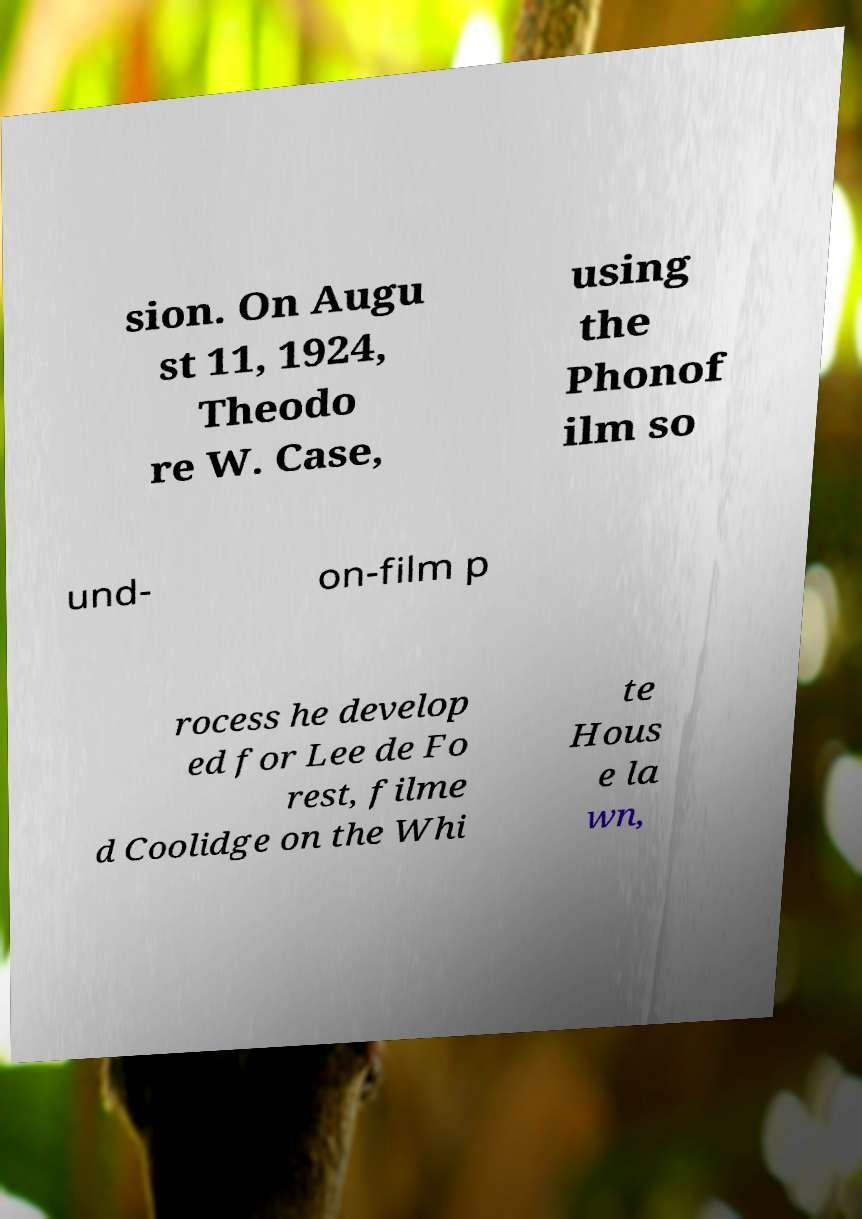I need the written content from this picture converted into text. Can you do that? sion. On Augu st 11, 1924, Theodo re W. Case, using the Phonof ilm so und- on-film p rocess he develop ed for Lee de Fo rest, filme d Coolidge on the Whi te Hous e la wn, 